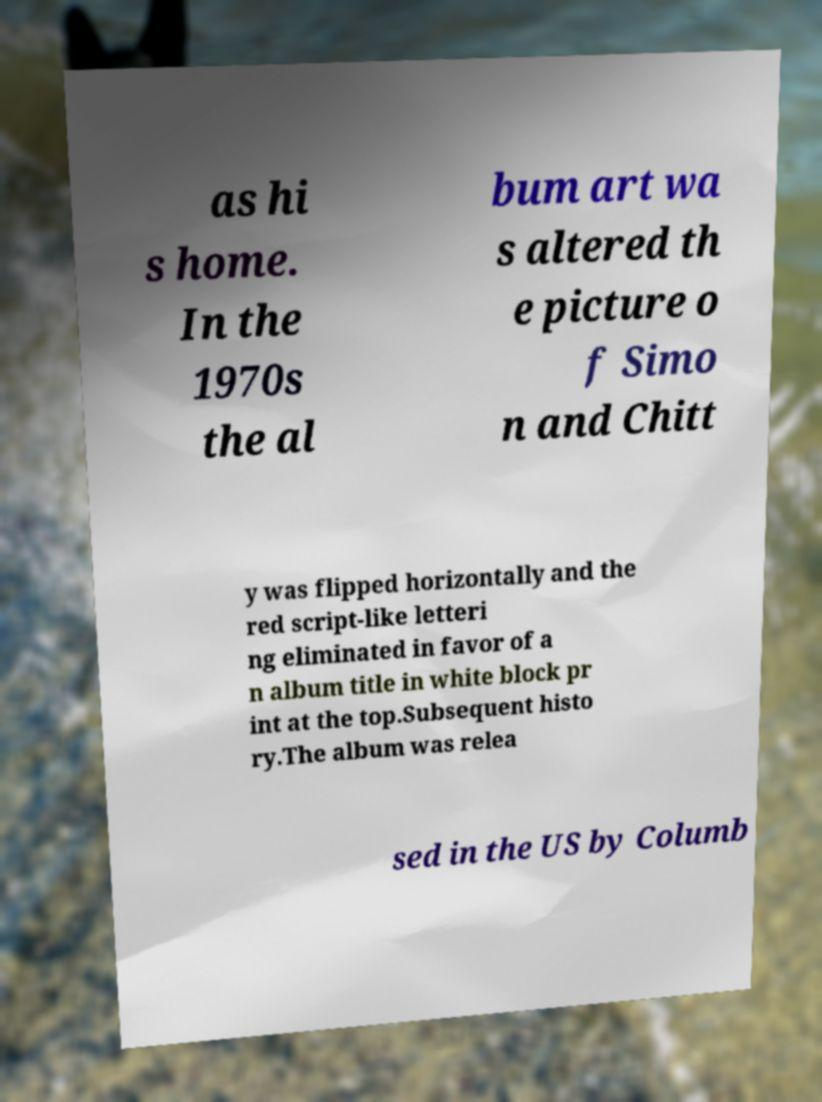Can you read and provide the text displayed in the image?This photo seems to have some interesting text. Can you extract and type it out for me? as hi s home. In the 1970s the al bum art wa s altered th e picture o f Simo n and Chitt y was flipped horizontally and the red script-like letteri ng eliminated in favor of a n album title in white block pr int at the top.Subsequent histo ry.The album was relea sed in the US by Columb 